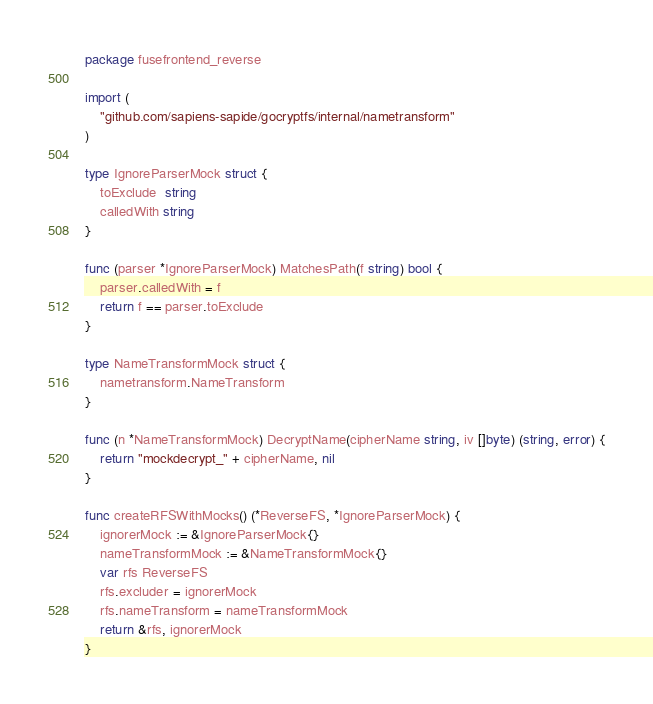<code> <loc_0><loc_0><loc_500><loc_500><_Go_>package fusefrontend_reverse

import (
	"github.com/sapiens-sapide/gocryptfs/internal/nametransform"
)

type IgnoreParserMock struct {
	toExclude  string
	calledWith string
}

func (parser *IgnoreParserMock) MatchesPath(f string) bool {
	parser.calledWith = f
	return f == parser.toExclude
}

type NameTransformMock struct {
	nametransform.NameTransform
}

func (n *NameTransformMock) DecryptName(cipherName string, iv []byte) (string, error) {
	return "mockdecrypt_" + cipherName, nil
}

func createRFSWithMocks() (*ReverseFS, *IgnoreParserMock) {
	ignorerMock := &IgnoreParserMock{}
	nameTransformMock := &NameTransformMock{}
	var rfs ReverseFS
	rfs.excluder = ignorerMock
	rfs.nameTransform = nameTransformMock
	return &rfs, ignorerMock
}
</code> 